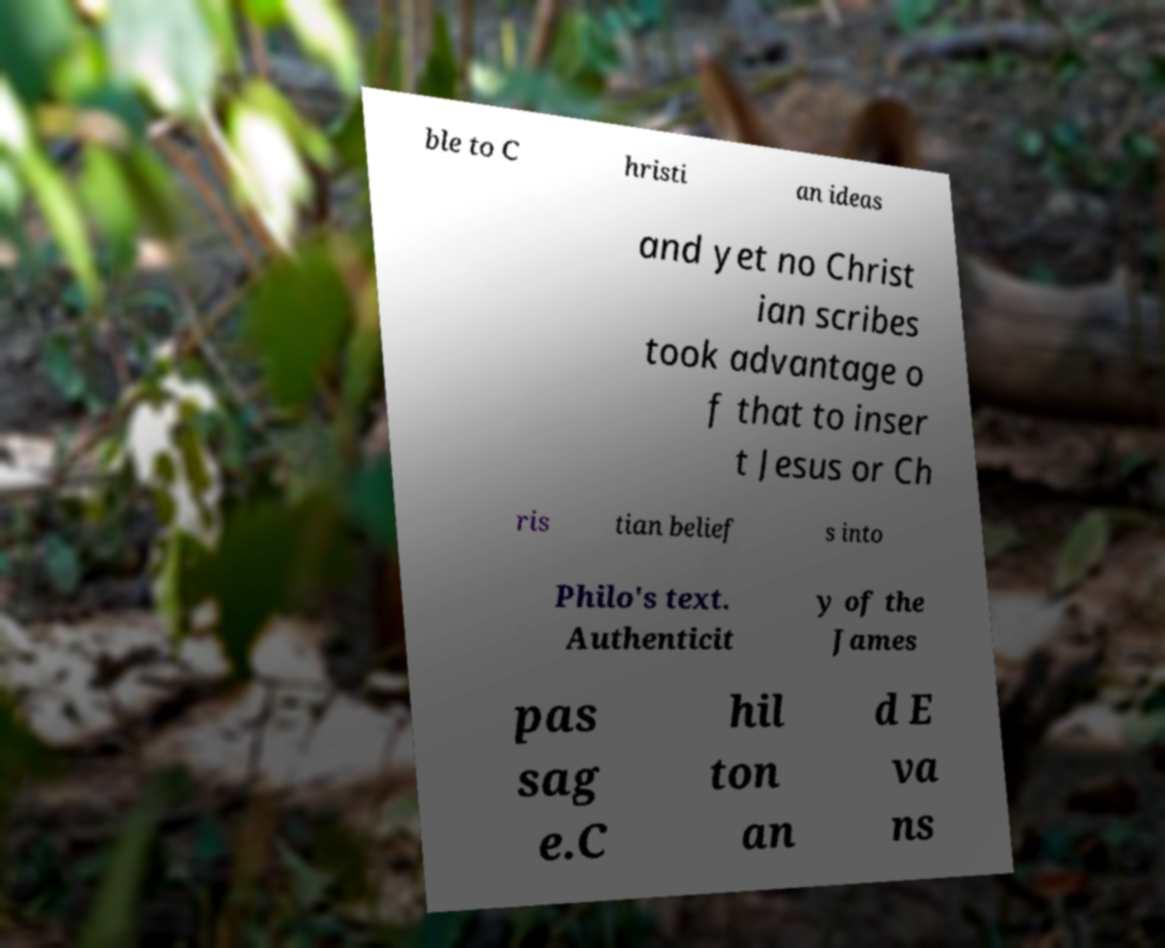For documentation purposes, I need the text within this image transcribed. Could you provide that? ble to C hristi an ideas and yet no Christ ian scribes took advantage o f that to inser t Jesus or Ch ris tian belief s into Philo's text. Authenticit y of the James pas sag e.C hil ton an d E va ns 